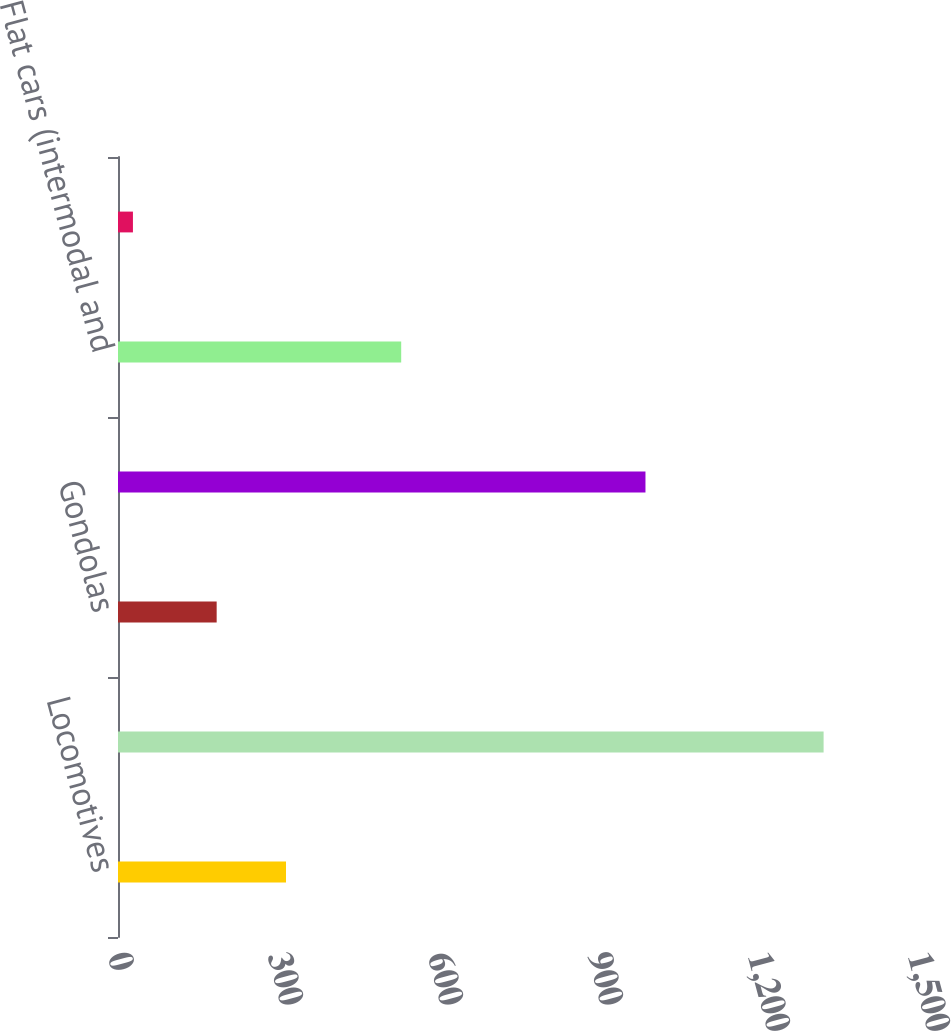Convert chart to OTSL. <chart><loc_0><loc_0><loc_500><loc_500><bar_chart><fcel>Locomotives<fcel>Box cars<fcel>Gondolas<fcel>Covered hoppers<fcel>Flat cars (intermodal and<fcel>Tank cars<nl><fcel>315<fcel>1323<fcel>185<fcel>989<fcel>531<fcel>28<nl></chart> 